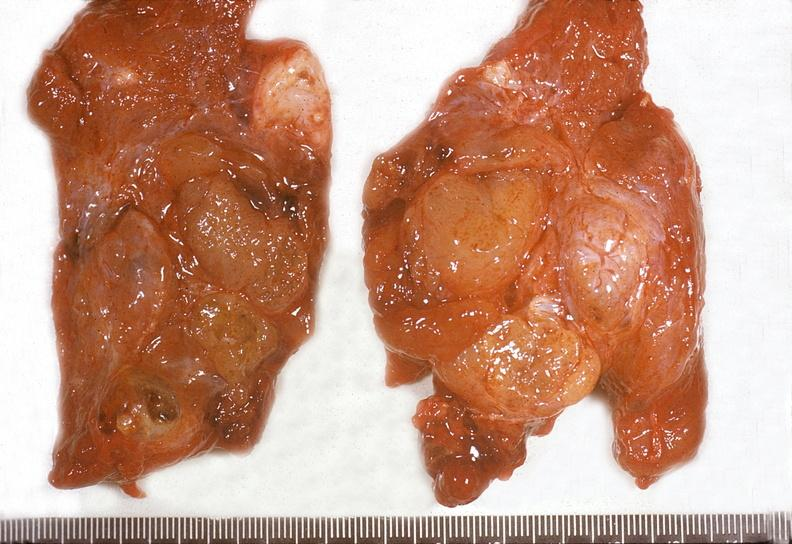what is present?
Answer the question using a single word or phrase. Endocrine 